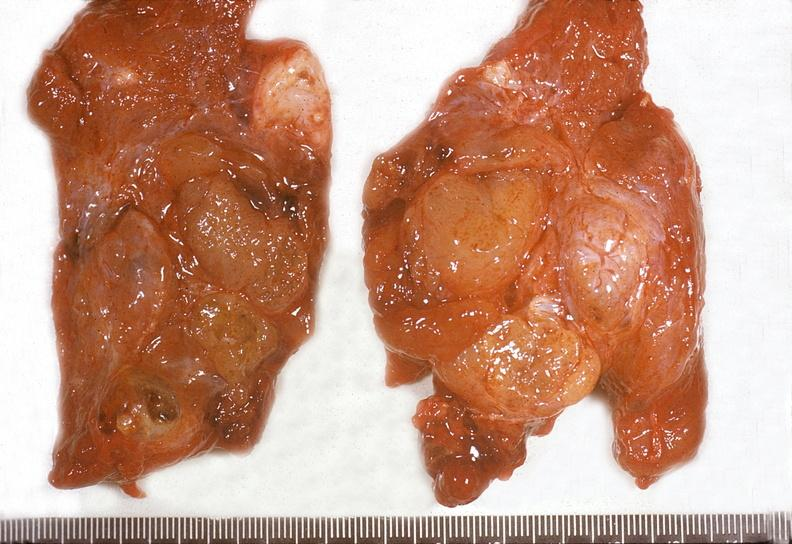what is present?
Answer the question using a single word or phrase. Endocrine 